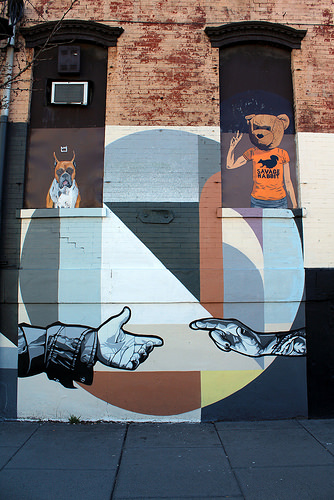<image>
Is there a hands in front of the boxer? No. The hands is not in front of the boxer. The spatial positioning shows a different relationship between these objects. 